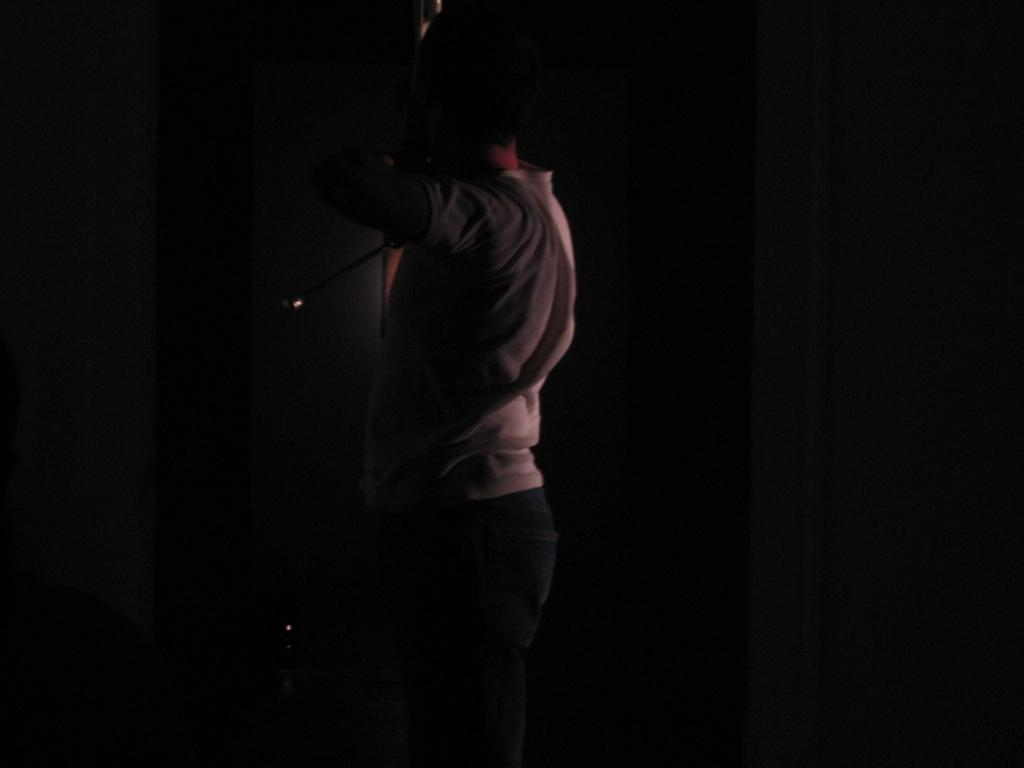What is the main subject of the image? There is a person standing in the image. Can you describe the lighting in the image? The image is a little dark. What type of clam is being used as a hat by the person in the image? There is no clam present in the image, and the person is not wearing a hat. How many dimes can be seen on the ground in the image? There are no dimes visible in the image. 